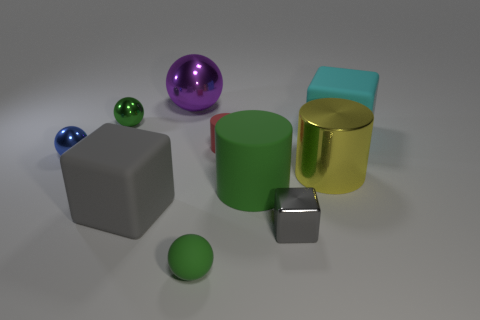Subtract all blocks. How many objects are left? 7 Subtract all large yellow metal objects. Subtract all large rubber objects. How many objects are left? 6 Add 6 balls. How many balls are left? 10 Add 7 large green balls. How many large green balls exist? 7 Subtract 1 cyan blocks. How many objects are left? 9 